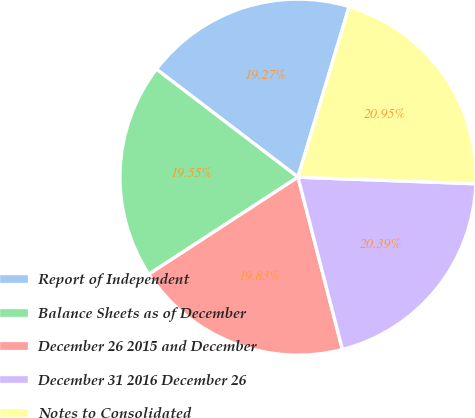<chart> <loc_0><loc_0><loc_500><loc_500><pie_chart><fcel>Report of Independent<fcel>Balance Sheets as of December<fcel>December 26 2015 and December<fcel>December 31 2016 December 26<fcel>Notes to Consolidated<nl><fcel>19.27%<fcel>19.55%<fcel>19.83%<fcel>20.39%<fcel>20.95%<nl></chart> 